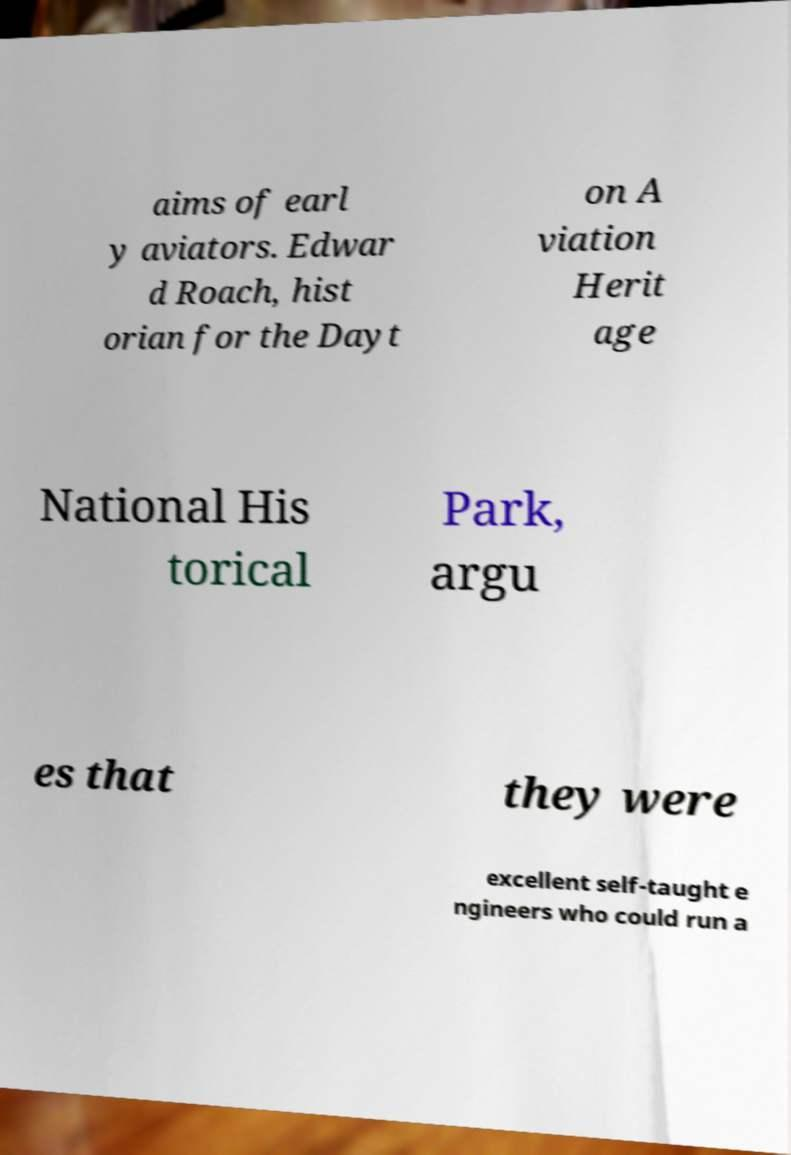Please read and relay the text visible in this image. What does it say? aims of earl y aviators. Edwar d Roach, hist orian for the Dayt on A viation Herit age National His torical Park, argu es that they were excellent self-taught e ngineers who could run a 